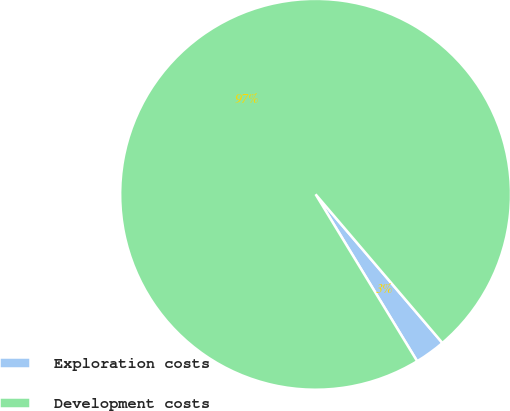Convert chart to OTSL. <chart><loc_0><loc_0><loc_500><loc_500><pie_chart><fcel>Exploration costs<fcel>Development costs<nl><fcel>2.54%<fcel>97.46%<nl></chart> 